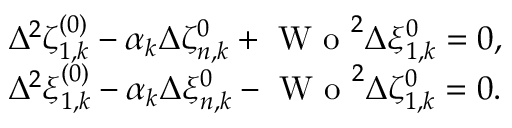Convert formula to latex. <formula><loc_0><loc_0><loc_500><loc_500>\begin{array} { r l } & { \Delta ^ { 2 } \zeta _ { 1 , k } ^ { ( 0 ) } - \alpha _ { k } \Delta \zeta _ { n , k } ^ { 0 } + W o ^ { 2 } \Delta \xi _ { 1 , k } ^ { 0 } = 0 , } \\ & { \Delta ^ { 2 } \xi _ { 1 , k } ^ { ( 0 ) } - \alpha _ { k } \Delta \xi _ { n , k } ^ { 0 } - W o ^ { 2 } \Delta \zeta _ { 1 , k } ^ { 0 } = 0 . } \end{array}</formula> 